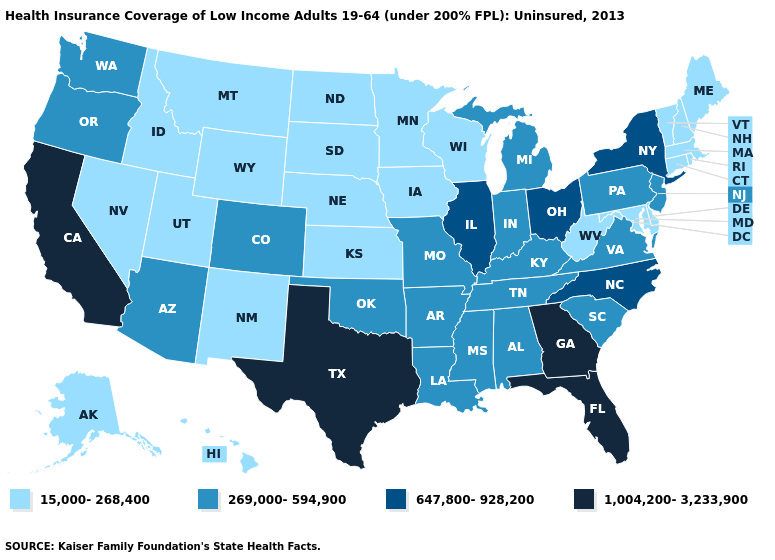Name the states that have a value in the range 15,000-268,400?
Be succinct. Alaska, Connecticut, Delaware, Hawaii, Idaho, Iowa, Kansas, Maine, Maryland, Massachusetts, Minnesota, Montana, Nebraska, Nevada, New Hampshire, New Mexico, North Dakota, Rhode Island, South Dakota, Utah, Vermont, West Virginia, Wisconsin, Wyoming. Does Michigan have the highest value in the USA?
Give a very brief answer. No. Name the states that have a value in the range 1,004,200-3,233,900?
Keep it brief. California, Florida, Georgia, Texas. What is the highest value in states that border Vermont?
Short answer required. 647,800-928,200. Does Pennsylvania have the lowest value in the Northeast?
Short answer required. No. What is the value of Utah?
Short answer required. 15,000-268,400. What is the value of Colorado?
Answer briefly. 269,000-594,900. What is the value of California?
Give a very brief answer. 1,004,200-3,233,900. Does Maine have a lower value than Arizona?
Be succinct. Yes. Does New York have the highest value in the Northeast?
Quick response, please. Yes. Does the map have missing data?
Quick response, please. No. Name the states that have a value in the range 647,800-928,200?
Concise answer only. Illinois, New York, North Carolina, Ohio. What is the value of North Dakota?
Answer briefly. 15,000-268,400. What is the value of Wisconsin?
Give a very brief answer. 15,000-268,400. Name the states that have a value in the range 269,000-594,900?
Write a very short answer. Alabama, Arizona, Arkansas, Colorado, Indiana, Kentucky, Louisiana, Michigan, Mississippi, Missouri, New Jersey, Oklahoma, Oregon, Pennsylvania, South Carolina, Tennessee, Virginia, Washington. 